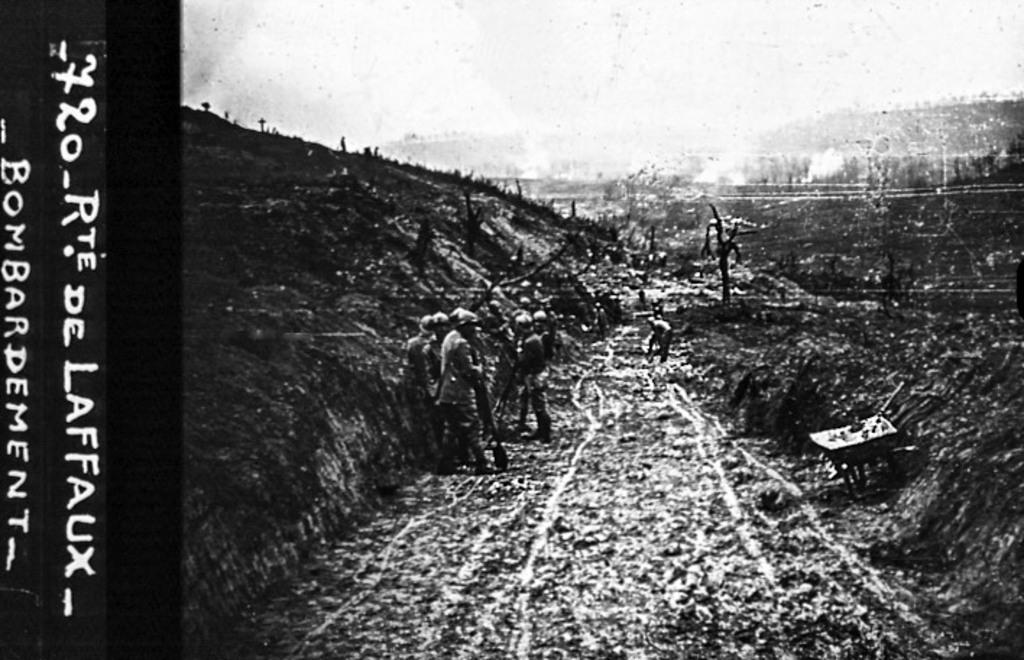What are the number listed?
Keep it short and to the point. 720. 